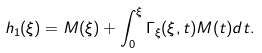Convert formula to latex. <formula><loc_0><loc_0><loc_500><loc_500>h _ { 1 } ( \xi ) = M ( \xi ) + \int _ { 0 } ^ { \xi } \Gamma _ { \xi } ( \xi , t ) M ( t ) d t .</formula> 